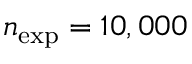<formula> <loc_0><loc_0><loc_500><loc_500>n _ { e x p } = 1 0 , 0 0 0</formula> 